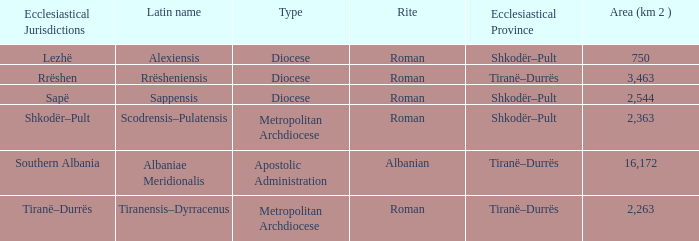What is Type for Rite Albanian? Apostolic Administration. 